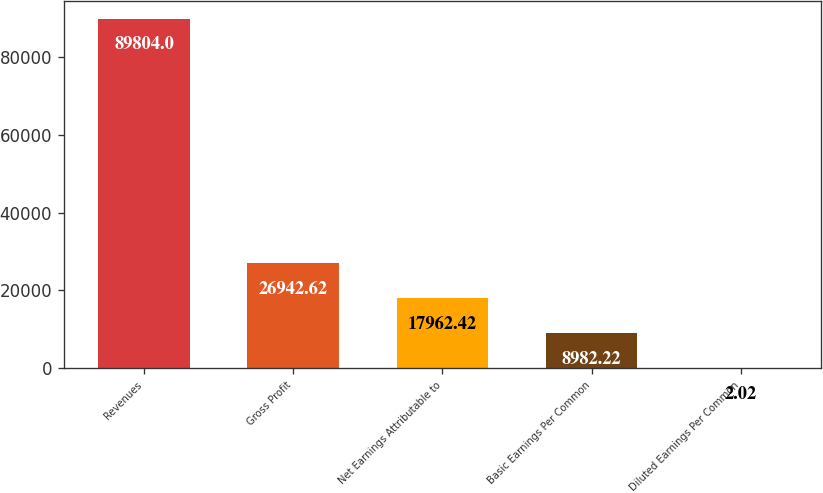Convert chart to OTSL. <chart><loc_0><loc_0><loc_500><loc_500><bar_chart><fcel>Revenues<fcel>Gross Profit<fcel>Net Earnings Attributable to<fcel>Basic Earnings Per Common<fcel>Diluted Earnings Per Common<nl><fcel>89804<fcel>26942.6<fcel>17962.4<fcel>8982.22<fcel>2.02<nl></chart> 